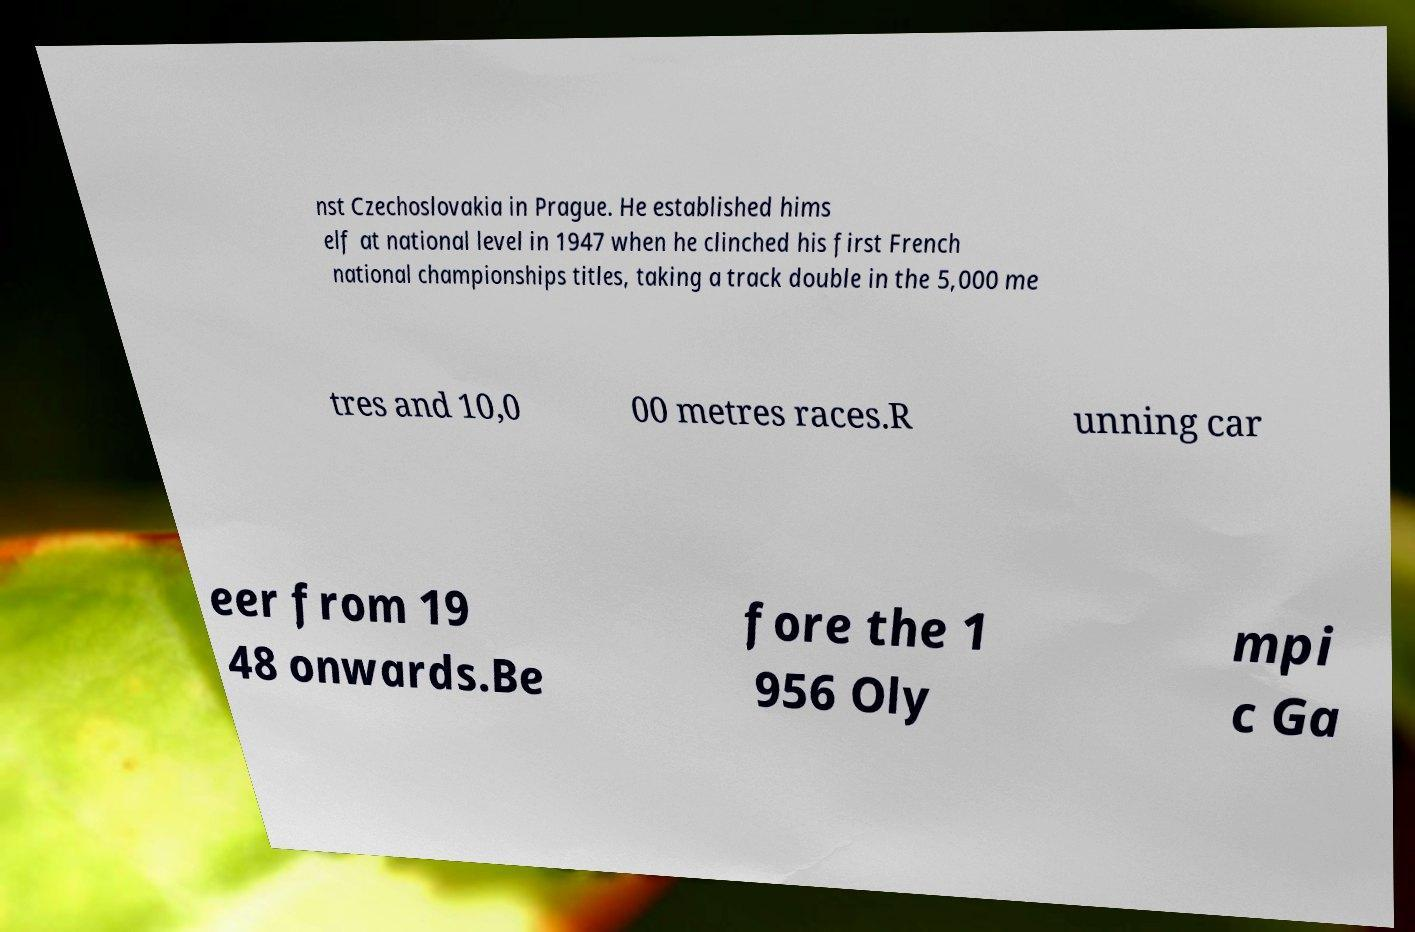Could you assist in decoding the text presented in this image and type it out clearly? nst Czechoslovakia in Prague. He established hims elf at national level in 1947 when he clinched his first French national championships titles, taking a track double in the 5,000 me tres and 10,0 00 metres races.R unning car eer from 19 48 onwards.Be fore the 1 956 Oly mpi c Ga 